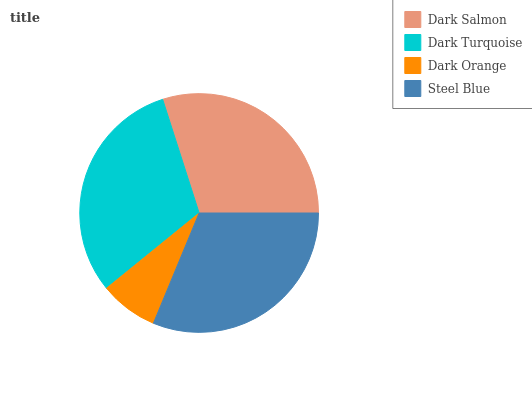Is Dark Orange the minimum?
Answer yes or no. Yes. Is Steel Blue the maximum?
Answer yes or no. Yes. Is Dark Turquoise the minimum?
Answer yes or no. No. Is Dark Turquoise the maximum?
Answer yes or no. No. Is Dark Turquoise greater than Dark Salmon?
Answer yes or no. Yes. Is Dark Salmon less than Dark Turquoise?
Answer yes or no. Yes. Is Dark Salmon greater than Dark Turquoise?
Answer yes or no. No. Is Dark Turquoise less than Dark Salmon?
Answer yes or no. No. Is Dark Turquoise the high median?
Answer yes or no. Yes. Is Dark Salmon the low median?
Answer yes or no. Yes. Is Dark Salmon the high median?
Answer yes or no. No. Is Dark Turquoise the low median?
Answer yes or no. No. 